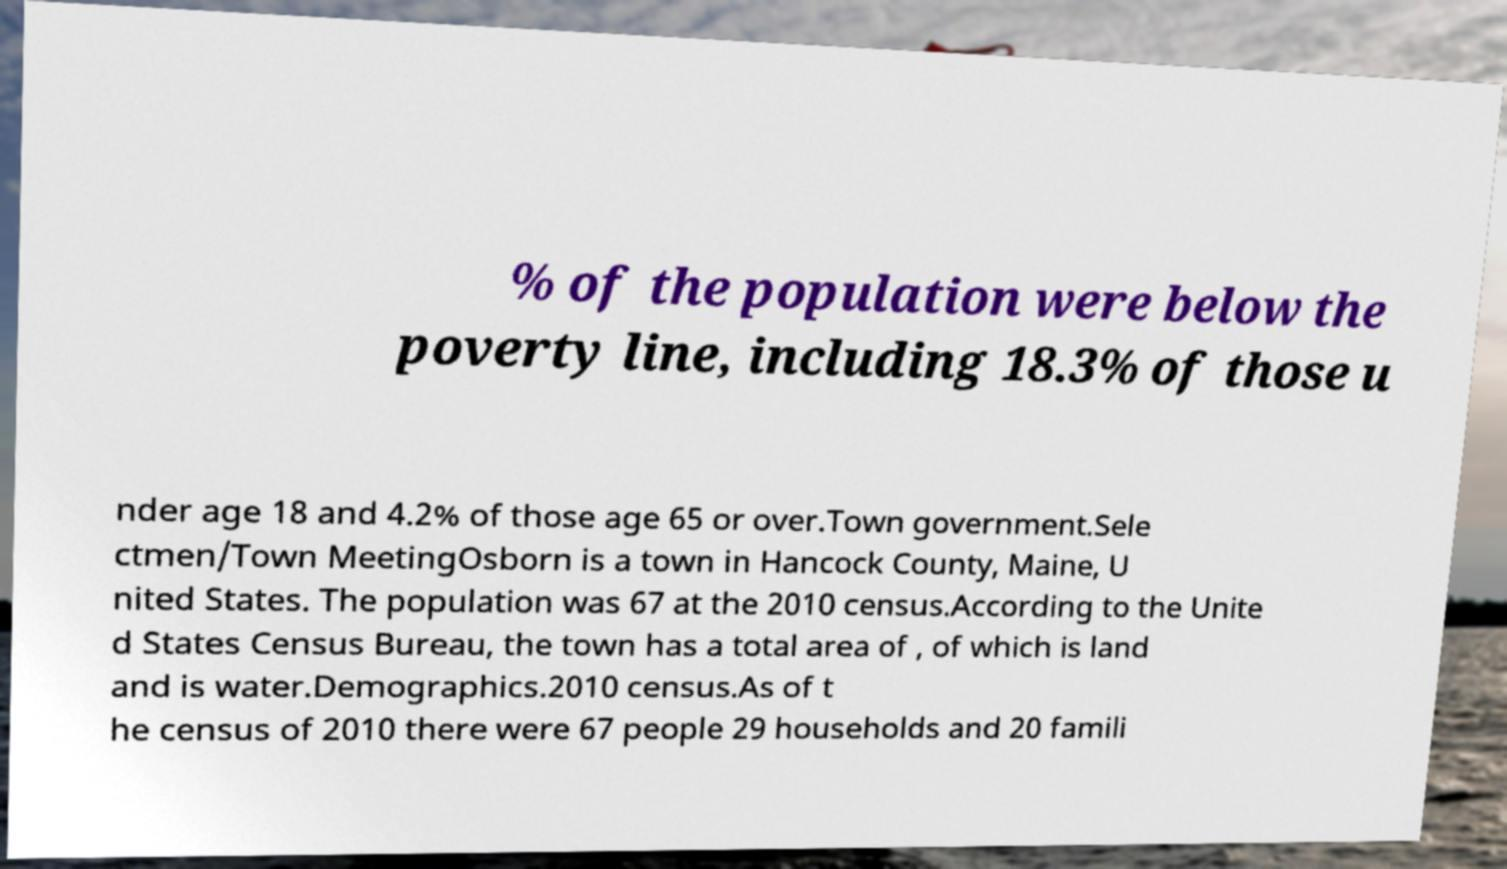Could you assist in decoding the text presented in this image and type it out clearly? % of the population were below the poverty line, including 18.3% of those u nder age 18 and 4.2% of those age 65 or over.Town government.Sele ctmen/Town MeetingOsborn is a town in Hancock County, Maine, U nited States. The population was 67 at the 2010 census.According to the Unite d States Census Bureau, the town has a total area of , of which is land and is water.Demographics.2010 census.As of t he census of 2010 there were 67 people 29 households and 20 famili 